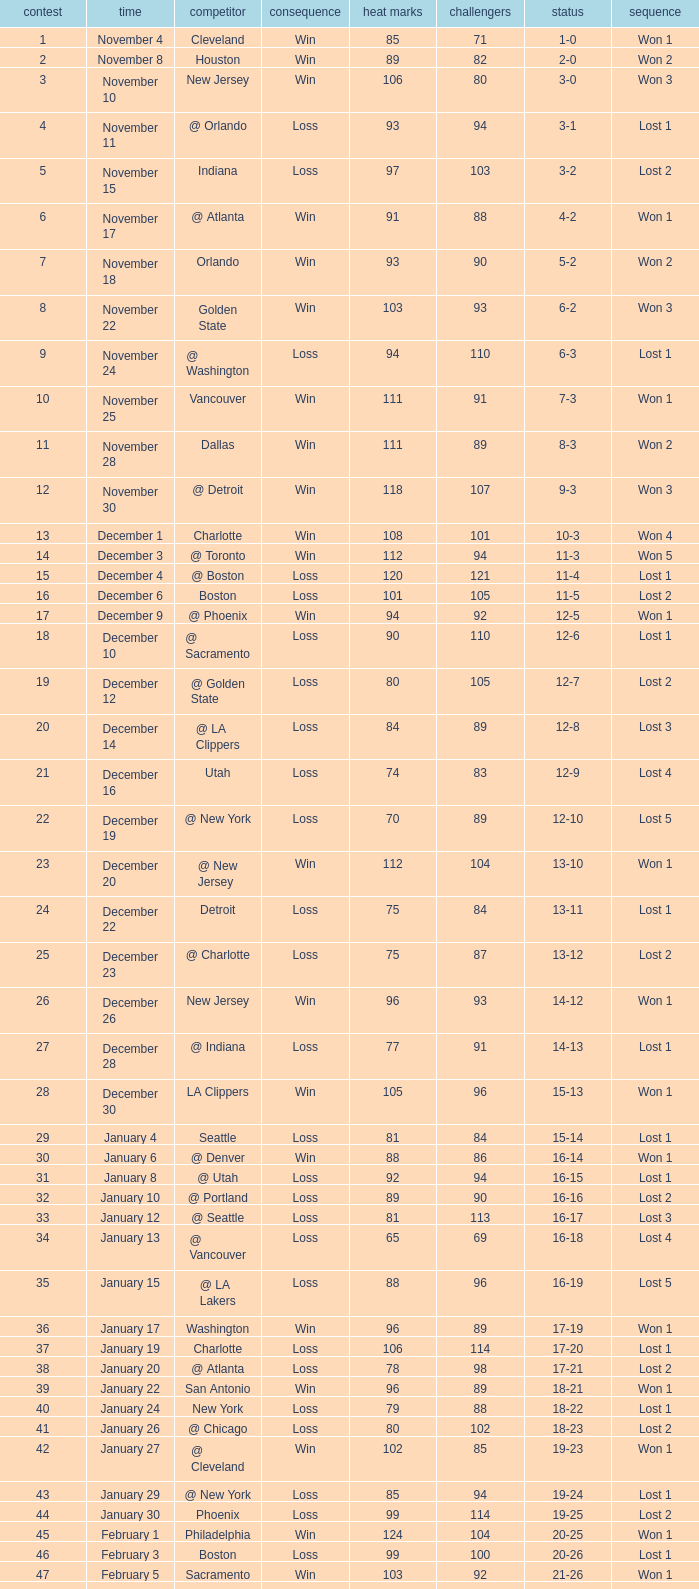Would you be able to parse every entry in this table? {'header': ['contest', 'time', 'competitor', 'consequence', 'heat marks', 'challengers', 'status', 'sequence'], 'rows': [['1', 'November 4', 'Cleveland', 'Win', '85', '71', '1-0', 'Won 1'], ['2', 'November 8', 'Houston', 'Win', '89', '82', '2-0', 'Won 2'], ['3', 'November 10', 'New Jersey', 'Win', '106', '80', '3-0', 'Won 3'], ['4', 'November 11', '@ Orlando', 'Loss', '93', '94', '3-1', 'Lost 1'], ['5', 'November 15', 'Indiana', 'Loss', '97', '103', '3-2', 'Lost 2'], ['6', 'November 17', '@ Atlanta', 'Win', '91', '88', '4-2', 'Won 1'], ['7', 'November 18', 'Orlando', 'Win', '93', '90', '5-2', 'Won 2'], ['8', 'November 22', 'Golden State', 'Win', '103', '93', '6-2', 'Won 3'], ['9', 'November 24', '@ Washington', 'Loss', '94', '110', '6-3', 'Lost 1'], ['10', 'November 25', 'Vancouver', 'Win', '111', '91', '7-3', 'Won 1'], ['11', 'November 28', 'Dallas', 'Win', '111', '89', '8-3', 'Won 2'], ['12', 'November 30', '@ Detroit', 'Win', '118', '107', '9-3', 'Won 3'], ['13', 'December 1', 'Charlotte', 'Win', '108', '101', '10-3', 'Won 4'], ['14', 'December 3', '@ Toronto', 'Win', '112', '94', '11-3', 'Won 5'], ['15', 'December 4', '@ Boston', 'Loss', '120', '121', '11-4', 'Lost 1'], ['16', 'December 6', 'Boston', 'Loss', '101', '105', '11-5', 'Lost 2'], ['17', 'December 9', '@ Phoenix', 'Win', '94', '92', '12-5', 'Won 1'], ['18', 'December 10', '@ Sacramento', 'Loss', '90', '110', '12-6', 'Lost 1'], ['19', 'December 12', '@ Golden State', 'Loss', '80', '105', '12-7', 'Lost 2'], ['20', 'December 14', '@ LA Clippers', 'Loss', '84', '89', '12-8', 'Lost 3'], ['21', 'December 16', 'Utah', 'Loss', '74', '83', '12-9', 'Lost 4'], ['22', 'December 19', '@ New York', 'Loss', '70', '89', '12-10', 'Lost 5'], ['23', 'December 20', '@ New Jersey', 'Win', '112', '104', '13-10', 'Won 1'], ['24', 'December 22', 'Detroit', 'Loss', '75', '84', '13-11', 'Lost 1'], ['25', 'December 23', '@ Charlotte', 'Loss', '75', '87', '13-12', 'Lost 2'], ['26', 'December 26', 'New Jersey', 'Win', '96', '93', '14-12', 'Won 1'], ['27', 'December 28', '@ Indiana', 'Loss', '77', '91', '14-13', 'Lost 1'], ['28', 'December 30', 'LA Clippers', 'Win', '105', '96', '15-13', 'Won 1'], ['29', 'January 4', 'Seattle', 'Loss', '81', '84', '15-14', 'Lost 1'], ['30', 'January 6', '@ Denver', 'Win', '88', '86', '16-14', 'Won 1'], ['31', 'January 8', '@ Utah', 'Loss', '92', '94', '16-15', 'Lost 1'], ['32', 'January 10', '@ Portland', 'Loss', '89', '90', '16-16', 'Lost 2'], ['33', 'January 12', '@ Seattle', 'Loss', '81', '113', '16-17', 'Lost 3'], ['34', 'January 13', '@ Vancouver', 'Loss', '65', '69', '16-18', 'Lost 4'], ['35', 'January 15', '@ LA Lakers', 'Loss', '88', '96', '16-19', 'Lost 5'], ['36', 'January 17', 'Washington', 'Win', '96', '89', '17-19', 'Won 1'], ['37', 'January 19', 'Charlotte', 'Loss', '106', '114', '17-20', 'Lost 1'], ['38', 'January 20', '@ Atlanta', 'Loss', '78', '98', '17-21', 'Lost 2'], ['39', 'January 22', 'San Antonio', 'Win', '96', '89', '18-21', 'Won 1'], ['40', 'January 24', 'New York', 'Loss', '79', '88', '18-22', 'Lost 1'], ['41', 'January 26', '@ Chicago', 'Loss', '80', '102', '18-23', 'Lost 2'], ['42', 'January 27', '@ Cleveland', 'Win', '102', '85', '19-23', 'Won 1'], ['43', 'January 29', '@ New York', 'Loss', '85', '94', '19-24', 'Lost 1'], ['44', 'January 30', 'Phoenix', 'Loss', '99', '114', '19-25', 'Lost 2'], ['45', 'February 1', 'Philadelphia', 'Win', '124', '104', '20-25', 'Won 1'], ['46', 'February 3', 'Boston', 'Loss', '99', '100', '20-26', 'Lost 1'], ['47', 'February 5', 'Sacramento', 'Win', '103', '92', '21-26', 'Won 1'], ['48', 'February 7', 'Atlanta', 'Win', '101', '89', '22-26', 'Won 2'], ['49', 'February 13', 'Toronto', 'Loss', '87', '98', '22-27', 'Lost 1'], ['50', 'February 15', 'Denver', 'Win', '97', '91', '23-27', 'Won 1'], ['51', 'February 17', 'Orlando', 'Loss', '93', '95', '23-28', 'Lost 1'], ['52', 'February 19', '@ Cleveland', 'Loss', '70', '73', '23-29', 'Lost 2'], ['53', 'February 21', '@ Philadelphia', 'Win', '66', '57', '24-29', 'Won 1'], ['54', 'February 23', 'Chicago', 'Win', '113', '104', '25-29', 'Won 2'], ['55', 'February 25', 'Philadelphia', 'Win', '108', '101', '26-29', 'Won 3'], ['56', 'February 27', '@ New Jersey', 'Win', '93', '90', '27-29', 'Won 4'], ['57', 'February 28', '@ Orlando', 'Loss', '112', '116', '27-30', 'Lost 1'], ['58', 'March 1', 'Portland', 'Loss', '88', '102', '27-31', 'Lost 2'], ['59', 'March 3', '@ Minnesota', 'Loss', '87', '89', '27-32', 'Lost 3'], ['60', 'March 5', 'Minnesota', 'Win', '113', '72', '28-32', 'Won 1'], ['61', 'March 8', 'Toronto', 'Win', '109', '79', '29-32', 'Won 2'], ['62', 'March 10', 'Cleveland', 'Win', '88', '81', '30-32', 'Won 3'], ['63', 'March 12', '@ Dallas', 'Win', '125', '118', '31-32', 'Won 4'], ['64', 'March 14', '@ San Antonio', 'Loss', '100', '120', '31-33', 'Lost 1'], ['65', 'March 16', '@ Houston', 'Win', '121', '97', '32-33', 'Won 1'], ['66', 'March 20', 'Detroit', 'Win', '102', '93', '33-33', 'Won 2'], ['67', 'March 22', '@ Milwaukee', 'Win', '122', '106', '34-33', 'Won 3'], ['68', 'March 24', '@ Boston', 'Win', '111', '95', '35-33', 'Won 4'], ['69', 'March 27', 'LA Lakers', 'Loss', '95', '106', '35-34', 'Lost 1'], ['70', 'March 29', 'Washington', 'Win', '112', '93', '36-34', 'Won 1'], ['71', 'March 30', '@ Detroit', 'Win', '95', '85', '37-34', 'Won 2'], ['72', 'April 2', 'Chicago', 'Loss', '92', '110', '37-35', 'Lost 1'], ['73', 'April 4', '@ Chicago', 'Loss', '92', '100', '37-36', 'Lost 2'], ['74', 'April 6', '@ Indiana', 'Loss', '95', '99', '37-37', 'Lost 3'], ['75', 'April 8', '@ Washington', 'Loss', '99', '111', '37-38', 'Lost 4'], ['76', 'April 10', '@ Charlotte', 'Win', '116', '95', '38-38', 'Won 1'], ['77', 'April 11', 'Milwaukee', 'Win', '115', '105', '39-38', 'Won 2'], ['78', 'April 13', 'New York', 'Win', '103', '95', '40-38', 'Won 3'], ['79', 'April 15', 'New Jersey', 'Win', '110', '90', '41-38', 'Won 4'], ['80', 'April 17', '@ Philadelphia', 'Loss', '86', '90', '41-39', 'Lost 1'], ['81', 'April 19', '@ Milwaukee', 'Win', '106', '100', '42-39', 'Won 1'], ['82', 'April 21', 'Atlanta', 'Loss', '92', '104', '42-40', 'Lost 1'], ['1', 'April 26 (First Round)', '@ Chicago', 'Loss', '85', '102', '0-1', 'Lost 1'], ['2', 'April 28 (First Round)', '@ Chicago', 'Loss', '75', '106', '0-2', 'Lost 2'], ['3', 'May 1 (First Round)', 'Chicago', 'Loss', '91', '112', '0-3', 'Lost 3']]} What is the highest Game, when Opponents is less than 80, and when Record is "1-0"? 1.0. 